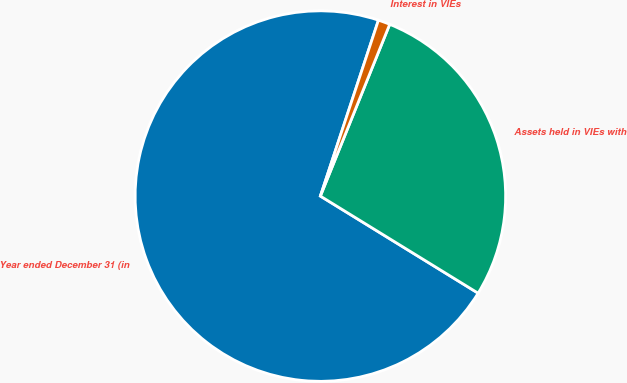Convert chart. <chart><loc_0><loc_0><loc_500><loc_500><pie_chart><fcel>Year ended December 31 (in<fcel>Assets held in VIEs with<fcel>Interest in VIEs<nl><fcel>71.3%<fcel>27.68%<fcel>1.03%<nl></chart> 